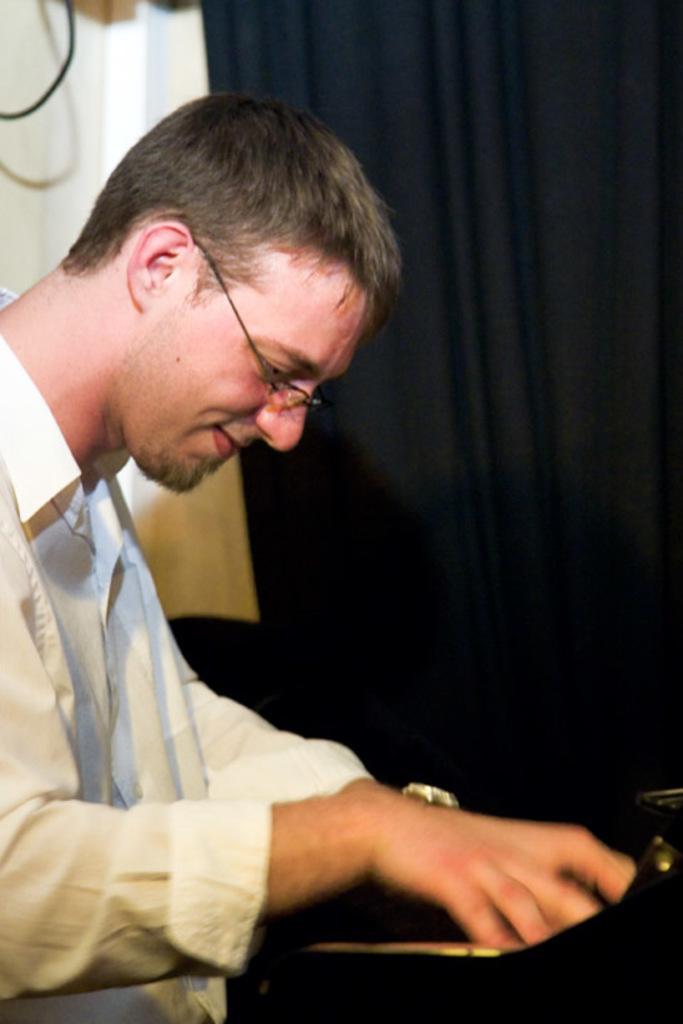In one or two sentences, can you explain what this image depicts? In this picture I can see a person with a smile wearing the spectacle. 